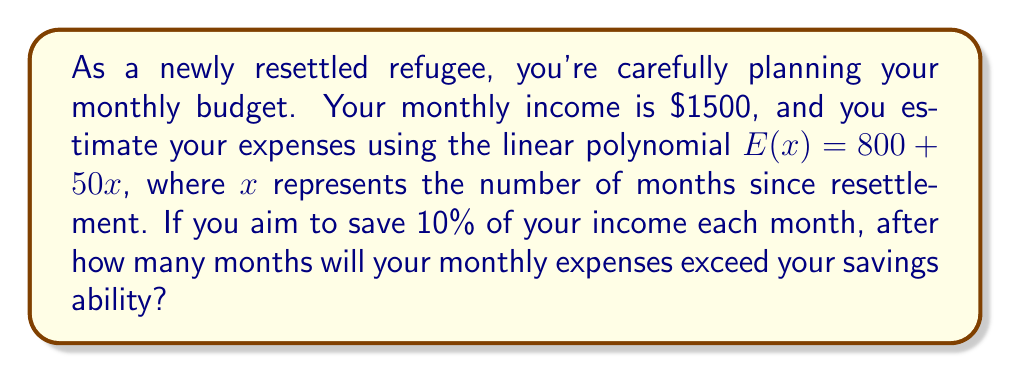Can you answer this question? Let's approach this step-by-step:

1) Your monthly income is $1500.

2) You aim to save 10% of your income each month:
   $1500 \times 10\% = $150$ in savings

3) This means you can spend up to $1350 per month:
   $1500 - $150 = $1350$

4) Your expenses are modeled by the linear polynomial:
   $E(x) = 800 + 50x$

5) We need to find when $E(x)$ exceeds $1350:
   $800 + 50x > 1350$

6) Solve this inequality:
   $50x > 550$
   $x > 11$

7) Since $x$ represents months and must be a whole number, we round up to the next integer.
Answer: After 12 months, your monthly expenses will exceed your savings ability. 